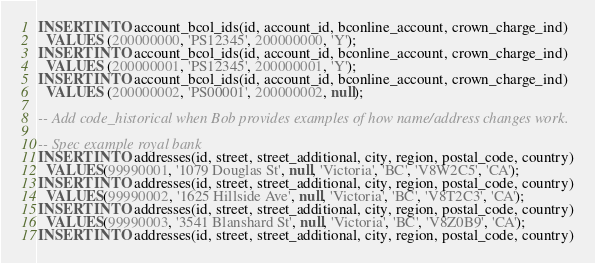<code> <loc_0><loc_0><loc_500><loc_500><_SQL_>INSERT INTO account_bcol_ids(id, account_id, bconline_account, crown_charge_ind)
  VALUES (200000000, 'PS12345', 200000000, 'Y');
INSERT INTO account_bcol_ids(id, account_id, bconline_account, crown_charge_ind)
  VALUES (200000001, 'PS12345', 200000001, 'Y');
INSERT INTO account_bcol_ids(id, account_id, bconline_account, crown_charge_ind)
  VALUES (200000002, 'PS00001', 200000002, null);

-- Add code_historical when Bob provides examples of how name/address changes work.

-- Spec example royal bank
INSERT INTO addresses(id, street, street_additional, city, region, postal_code, country)
  VALUES(99990001, '1079 Douglas St', null, 'Victoria', 'BC', 'V8W2C5', 'CA');
INSERT INTO addresses(id, street, street_additional, city, region, postal_code, country)
  VALUES(99990002, '1625 Hillside Ave', null, 'Victoria', 'BC', 'V8T2C3', 'CA');
INSERT INTO addresses(id, street, street_additional, city, region, postal_code, country)
  VALUES(99990003, '3541 Blanshard St', null, 'Victoria', 'BC', 'V8Z0B9', 'CA');
INSERT INTO addresses(id, street, street_additional, city, region, postal_code, country)</code> 